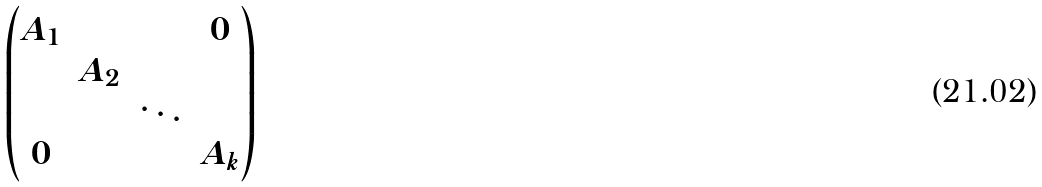Convert formula to latex. <formula><loc_0><loc_0><loc_500><loc_500>\begin{pmatrix} A _ { 1 } & & & 0 \\ & A _ { 2 } \\ & & \ddots \\ 0 & & & A _ { k } \end{pmatrix}</formula> 